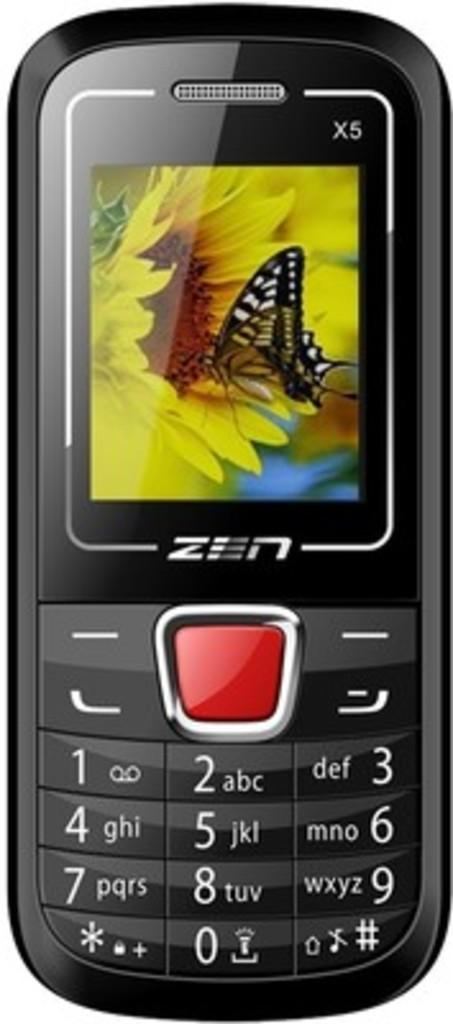<image>
Present a compact description of the photo's key features. An old fashioned cell phone with the word Zen below the screen. 